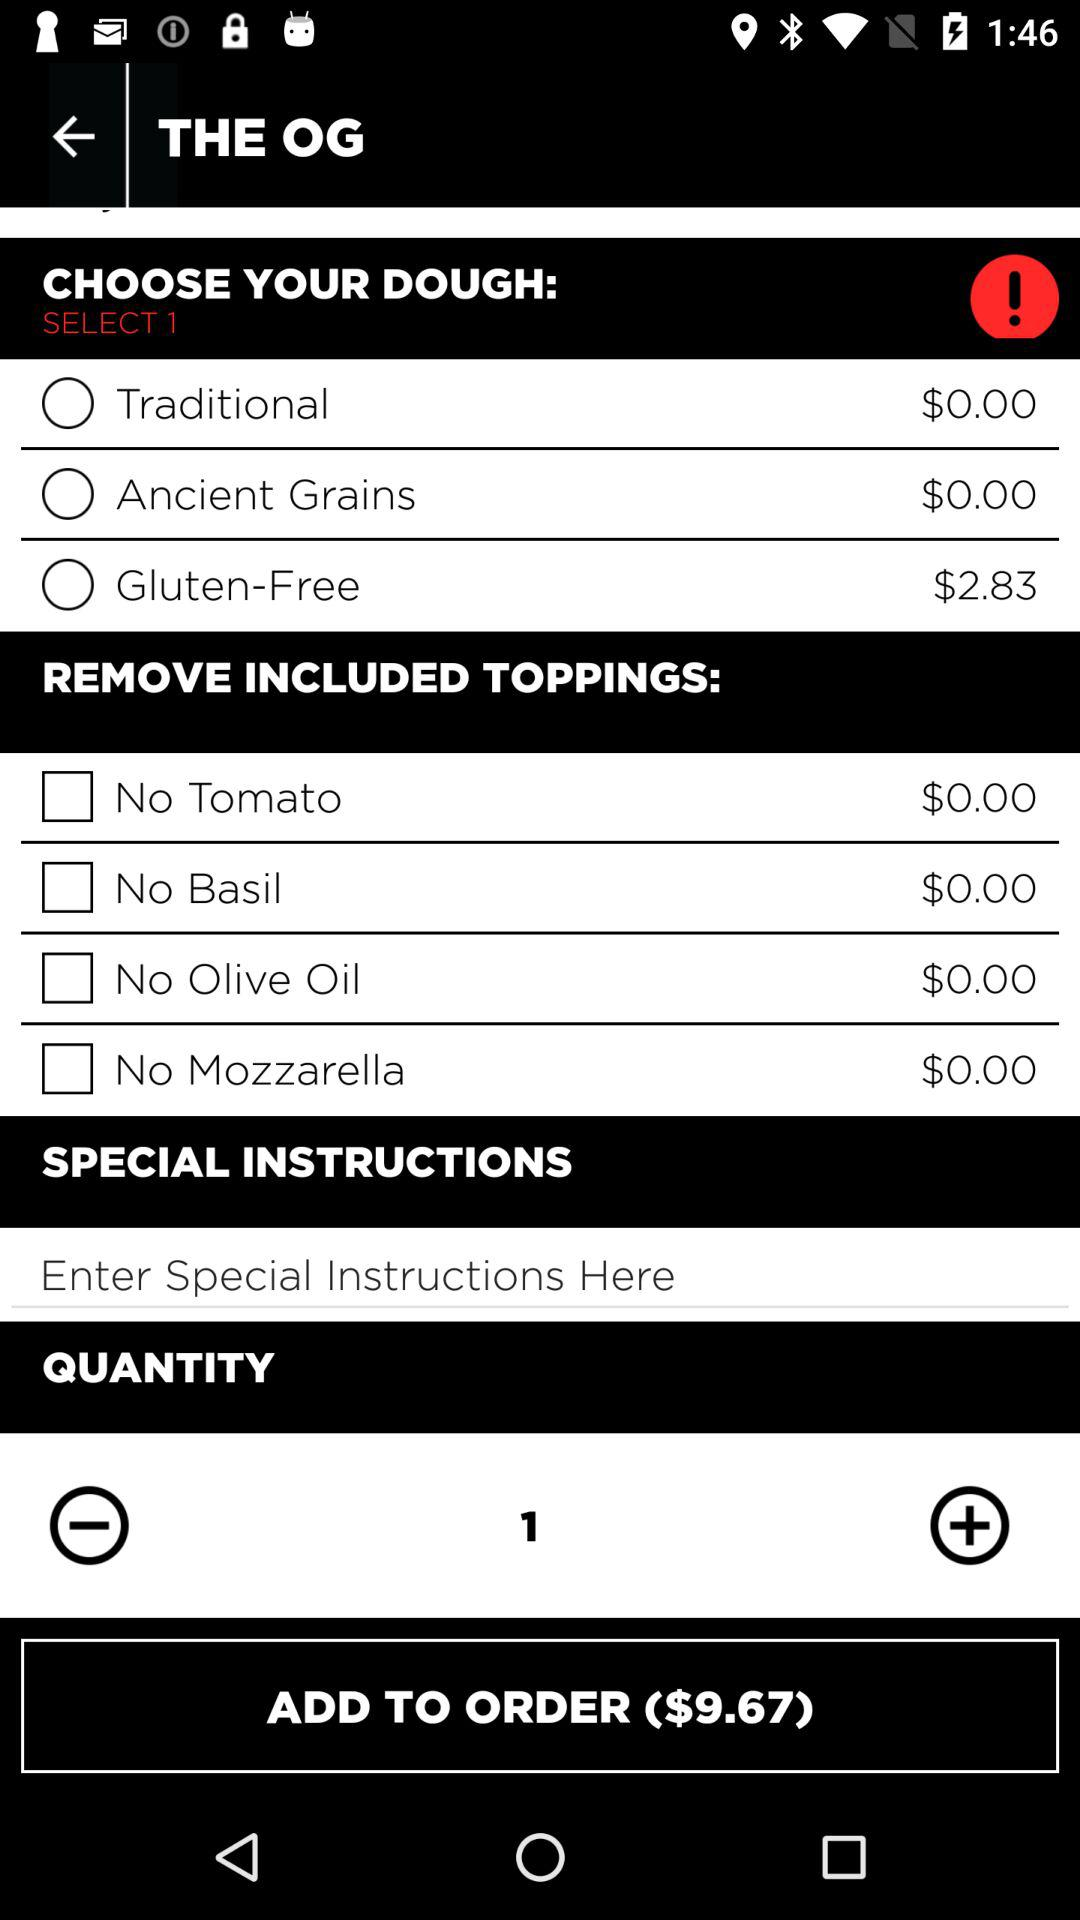What is the price of the ancient grains? The price is $0. 